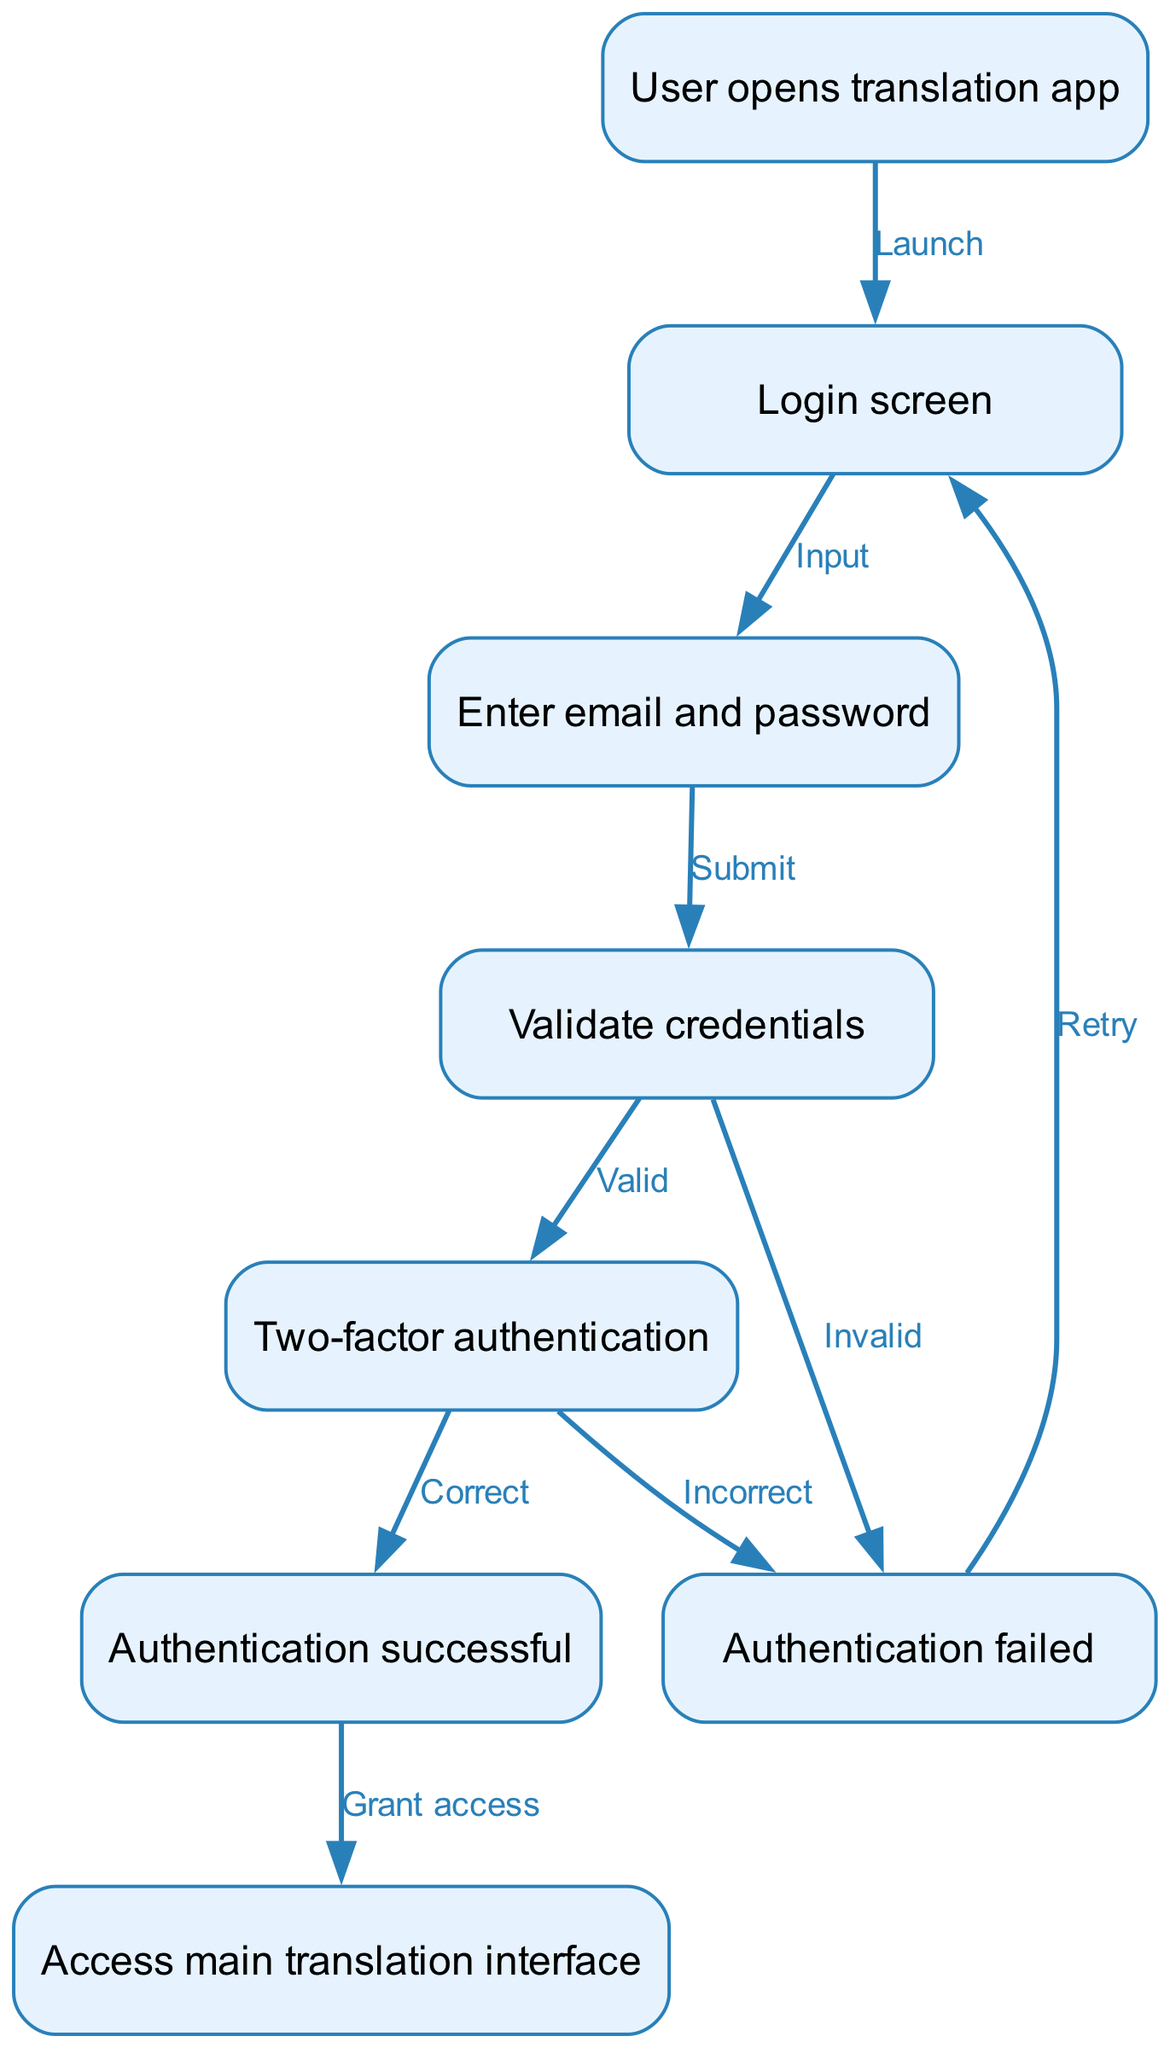What is the first action when the user opens the translation app? The first action in the diagram is labeled "User opens translation app," which is the starting point that leads to the login screen.
Answer: Login screen How many nodes are present in the flowchart? By counting the unique actions represented, there are eight distinct nodes in the diagram that detail the user authentication process.
Answer: 8 What happens if the user enters invalid credentials? If the user enters invalid credentials, the flowchart indicates that it leads to the "Authentication failed" node, which prompts the user to retry logging in.
Answer: Authentication failed What is the final node that a user accesses after successful authentication? The final outcome for a user who passes through the successful authentication process is to access the "main translation interface," which is where the user interacts with the translation app.
Answer: Access main translation interface What is required after validating credentials if they are valid? After validating credentials, if they are found to be valid, the next step is the "Two-factor authentication," which is necessary for enhancing security.
Answer: Two-factor authentication What action does the user take after reaching the login screen? The user needs to input their email and password at the login screen, which is necessary to proceed to the next step of the authentication flow.
Answer: Enter email and password What type of authentication is included in the flow? The flowchart specifies that "Two-factor authentication" is a requirement in the user authentication process, enhancing the security of user access.
Answer: Two-factor authentication How does the user get back to the login screen after a failed attempt? If authentication fails at any point, the flowchart shows that the user can return to the "login" node to retry entering their credentials.
Answer: Retry 